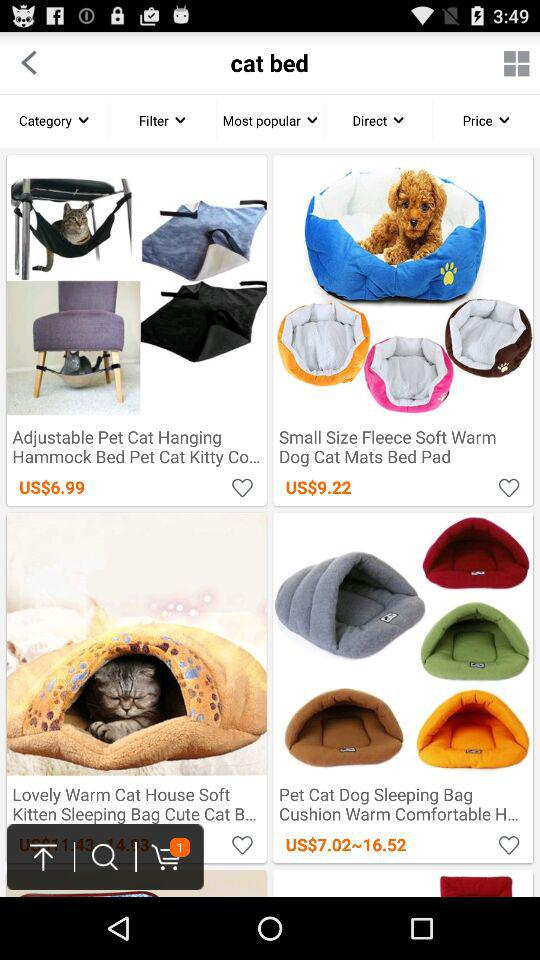What's the price of the "Small Size Fleece Soft Warm Dog Cat Mats Bed Pad"? The price of the "Small Size Fleece Soft Warm Dog Cat Mats Bed Pad" is US $9.22. 